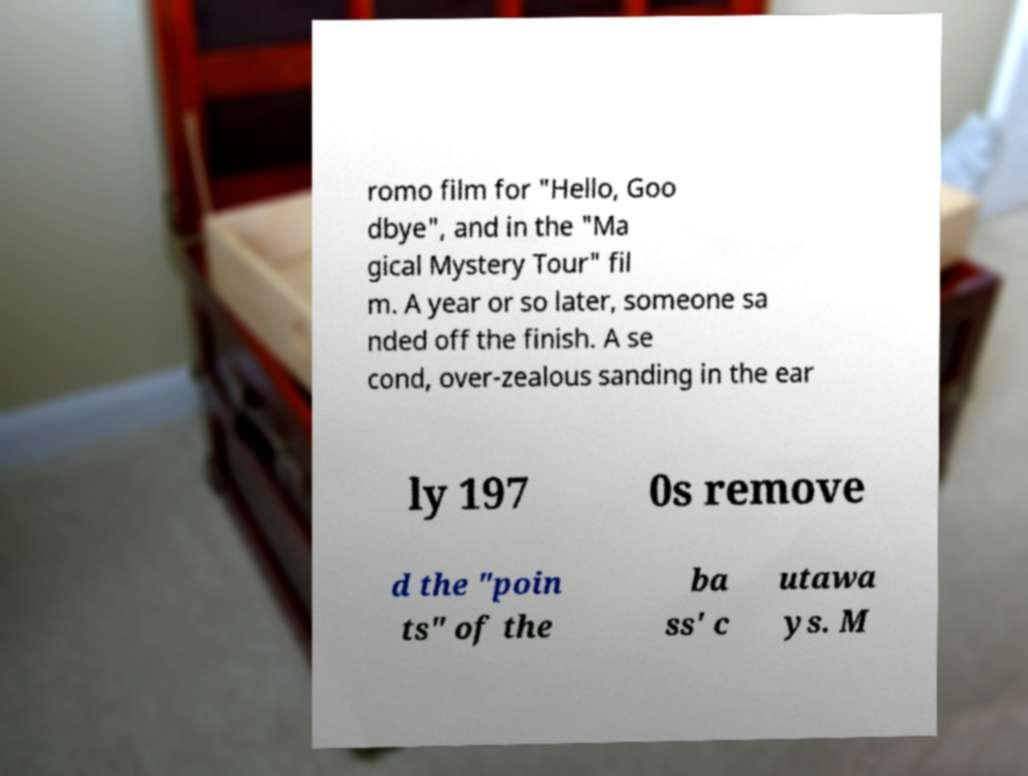I need the written content from this picture converted into text. Can you do that? romo film for "Hello, Goo dbye", and in the "Ma gical Mystery Tour" fil m. A year or so later, someone sa nded off the finish. A se cond, over-zealous sanding in the ear ly 197 0s remove d the "poin ts" of the ba ss' c utawa ys. M 